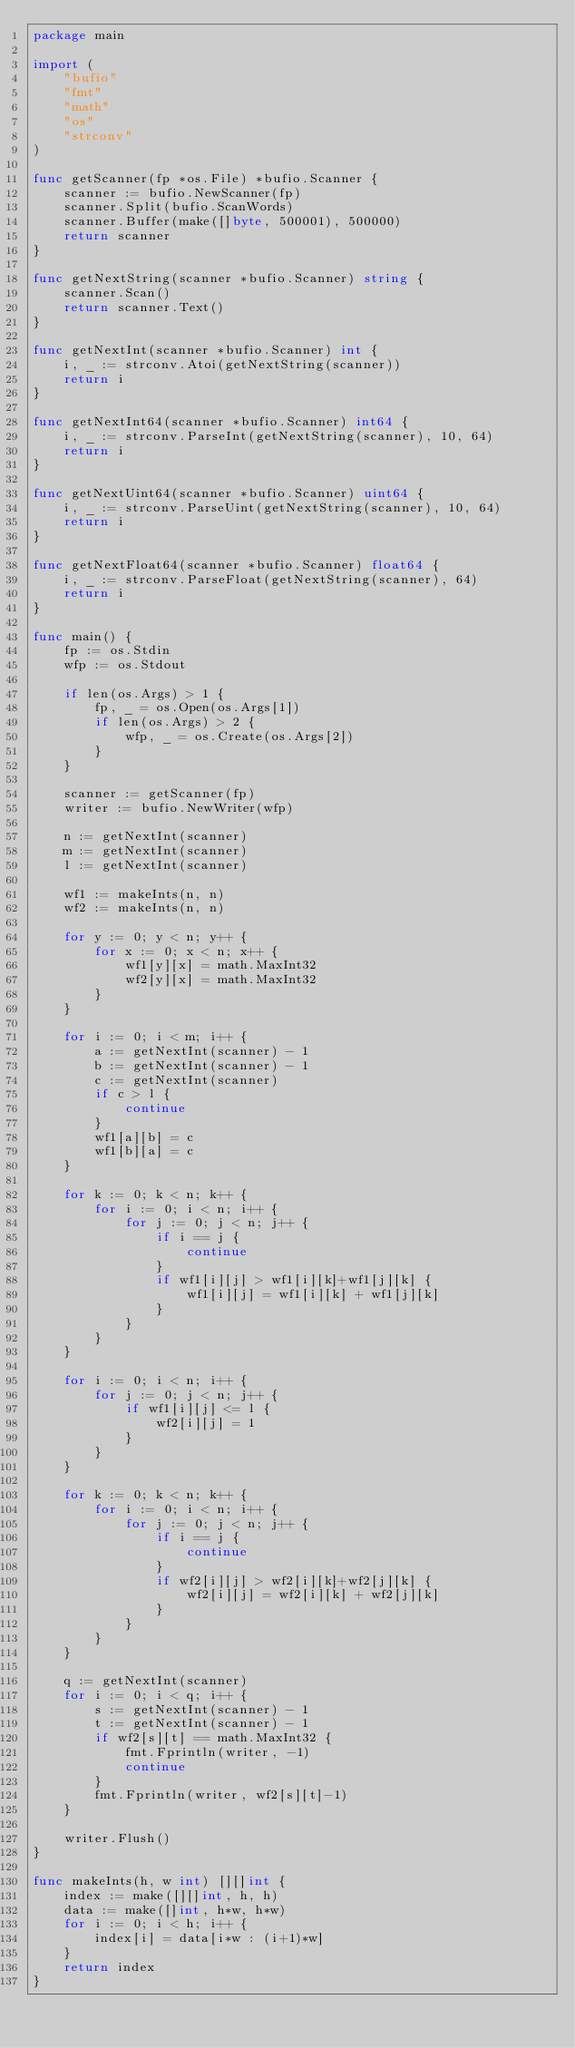Convert code to text. <code><loc_0><loc_0><loc_500><loc_500><_Go_>package main

import (
	"bufio"
	"fmt"
	"math"
	"os"
	"strconv"
)

func getScanner(fp *os.File) *bufio.Scanner {
	scanner := bufio.NewScanner(fp)
	scanner.Split(bufio.ScanWords)
	scanner.Buffer(make([]byte, 500001), 500000)
	return scanner
}

func getNextString(scanner *bufio.Scanner) string {
	scanner.Scan()
	return scanner.Text()
}

func getNextInt(scanner *bufio.Scanner) int {
	i, _ := strconv.Atoi(getNextString(scanner))
	return i
}

func getNextInt64(scanner *bufio.Scanner) int64 {
	i, _ := strconv.ParseInt(getNextString(scanner), 10, 64)
	return i
}

func getNextUint64(scanner *bufio.Scanner) uint64 {
	i, _ := strconv.ParseUint(getNextString(scanner), 10, 64)
	return i
}

func getNextFloat64(scanner *bufio.Scanner) float64 {
	i, _ := strconv.ParseFloat(getNextString(scanner), 64)
	return i
}

func main() {
	fp := os.Stdin
	wfp := os.Stdout

	if len(os.Args) > 1 {
		fp, _ = os.Open(os.Args[1])
		if len(os.Args) > 2 {
			wfp, _ = os.Create(os.Args[2])
		}
	}

	scanner := getScanner(fp)
	writer := bufio.NewWriter(wfp)

	n := getNextInt(scanner)
	m := getNextInt(scanner)
	l := getNextInt(scanner)

	wf1 := makeInts(n, n)
	wf2 := makeInts(n, n)

	for y := 0; y < n; y++ {
		for x := 0; x < n; x++ {
			wf1[y][x] = math.MaxInt32
			wf2[y][x] = math.MaxInt32
		}
	}

	for i := 0; i < m; i++ {
		a := getNextInt(scanner) - 1
		b := getNextInt(scanner) - 1
		c := getNextInt(scanner)
		if c > l {
			continue
		}
		wf1[a][b] = c
		wf1[b][a] = c
	}

	for k := 0; k < n; k++ {
		for i := 0; i < n; i++ {
			for j := 0; j < n; j++ {
				if i == j {
					continue
				}
				if wf1[i][j] > wf1[i][k]+wf1[j][k] {
					wf1[i][j] = wf1[i][k] + wf1[j][k]
				}
			}
		}
	}

	for i := 0; i < n; i++ {
		for j := 0; j < n; j++ {
			if wf1[i][j] <= l {
				wf2[i][j] = 1
			}
		}
	}

	for k := 0; k < n; k++ {
		for i := 0; i < n; i++ {
			for j := 0; j < n; j++ {
				if i == j {
					continue
				}
				if wf2[i][j] > wf2[i][k]+wf2[j][k] {
					wf2[i][j] = wf2[i][k] + wf2[j][k]
				}
			}
		}
	}

	q := getNextInt(scanner)
	for i := 0; i < q; i++ {
		s := getNextInt(scanner) - 1
		t := getNextInt(scanner) - 1
		if wf2[s][t] == math.MaxInt32 {
			fmt.Fprintln(writer, -1)
			continue
		}
		fmt.Fprintln(writer, wf2[s][t]-1)
	}

	writer.Flush()
}

func makeInts(h, w int) [][]int {
	index := make([][]int, h, h)
	data := make([]int, h*w, h*w)
	for i := 0; i < h; i++ {
		index[i] = data[i*w : (i+1)*w]
	}
	return index
}
</code> 